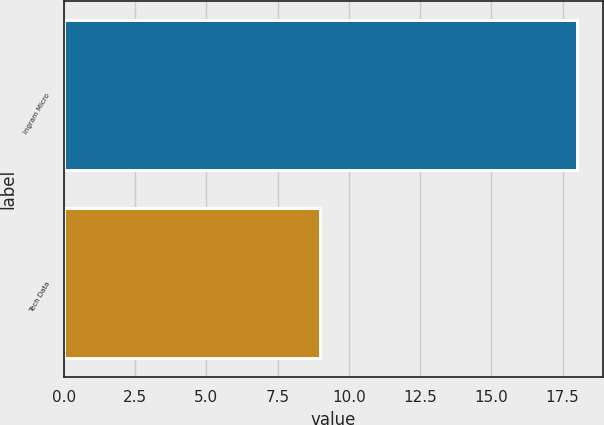Convert chart to OTSL. <chart><loc_0><loc_0><loc_500><loc_500><bar_chart><fcel>Ingram Micro<fcel>Tech Data<nl><fcel>18<fcel>9<nl></chart> 